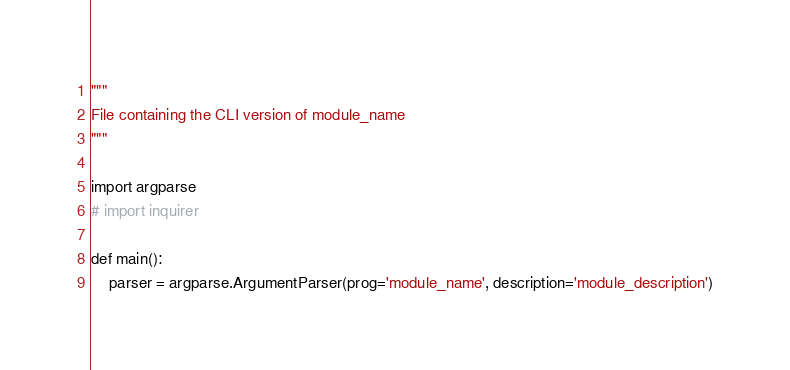<code> <loc_0><loc_0><loc_500><loc_500><_Python_>"""
File containing the CLI version of module_name
"""

import argparse
# import inquirer

def main():
    parser = argparse.ArgumentParser(prog='module_name', description='module_description')</code> 